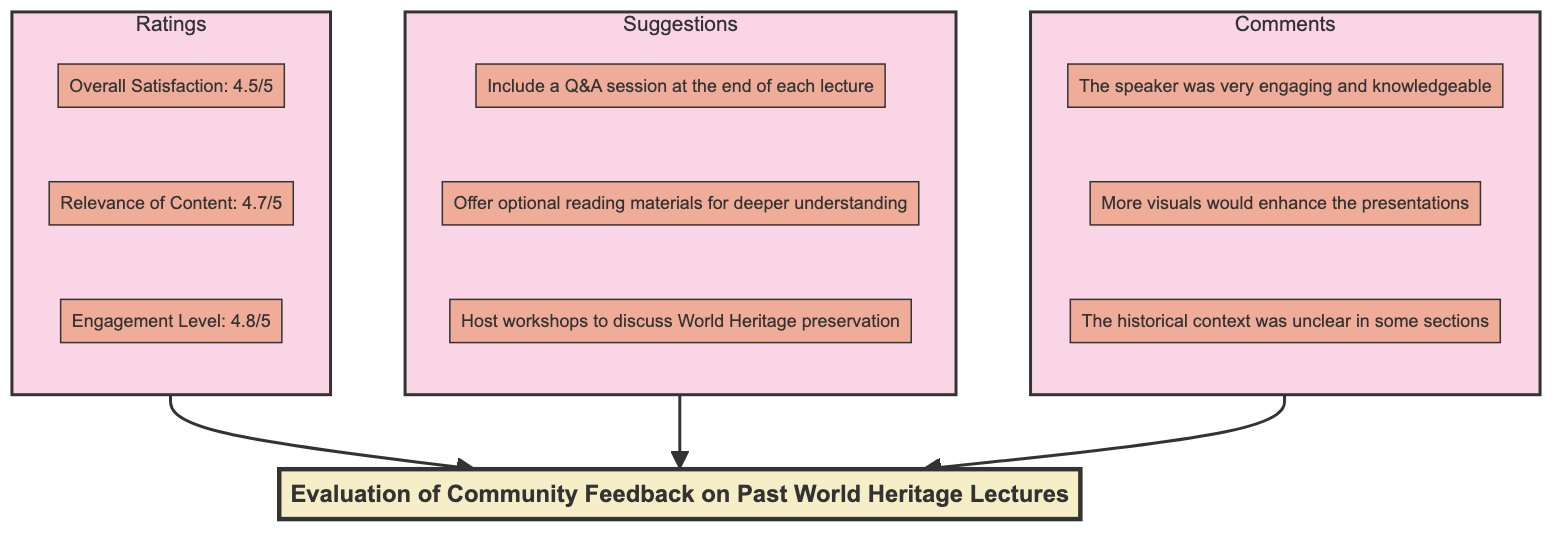What are the three main categories of feedback in the evaluation? The diagram shows three main categories: Ratings, Suggestions, and Comments. These are the top-level nodes connected to the main evaluation node.
Answer: Ratings, Suggestions, Comments What rating has the highest value? By examining the Ratings section, Engagement Level has the highest rating of 4.8 out of 5. It's necessary to compare all numeric values to determine the highest.
Answer: 4.8/5 How many suggestions are listed in the diagram? The Suggestions section contains three suggestions. Counting the sub-elements under the Suggestions node will give the total.
Answer: 3 Which comment indicates a need for better visuals? The comment "More visuals would enhance the presentations" directly addresses the need for improved visuals in the lectures. It can be identified within the Comments section.
Answer: More visuals would enhance the presentations What is the relationship between the Ratings and Suggestions categories? Both the Ratings and Suggestions categories are sub-elements that connect to the main node of Feedback Evaluation. They share the same level in the hierarchy as it pertains to evaluating the feedback.
Answer: Connected to Feedback Evaluation Are there more comments or suggestions in the evaluation? By counting the nodes under Comments (3) and Suggestions (3), we find that both categories have an equal number of entries, thus there are neither more comments nor suggestions.
Answer: Neither What type of feedback is the suggestion to include a Q&A session? The suggestion "Include a Q&A session at the end of each lecture" is categorized under Suggestions. This can be determined by identifying its placement in the graphic portion corresponding to Suggestions.
Answer: Suggestions Calculate the average rating from the provided ratings. To find the average, add the numerical values of the three ratings (4.5, 4.7, and 4.8) and divide by 3. The calculation yields (4.5 + 4.7 + 4.8)/3 = 4.667. It's essential to follow standard averaging procedure for confirmation.
Answer: 4.67 